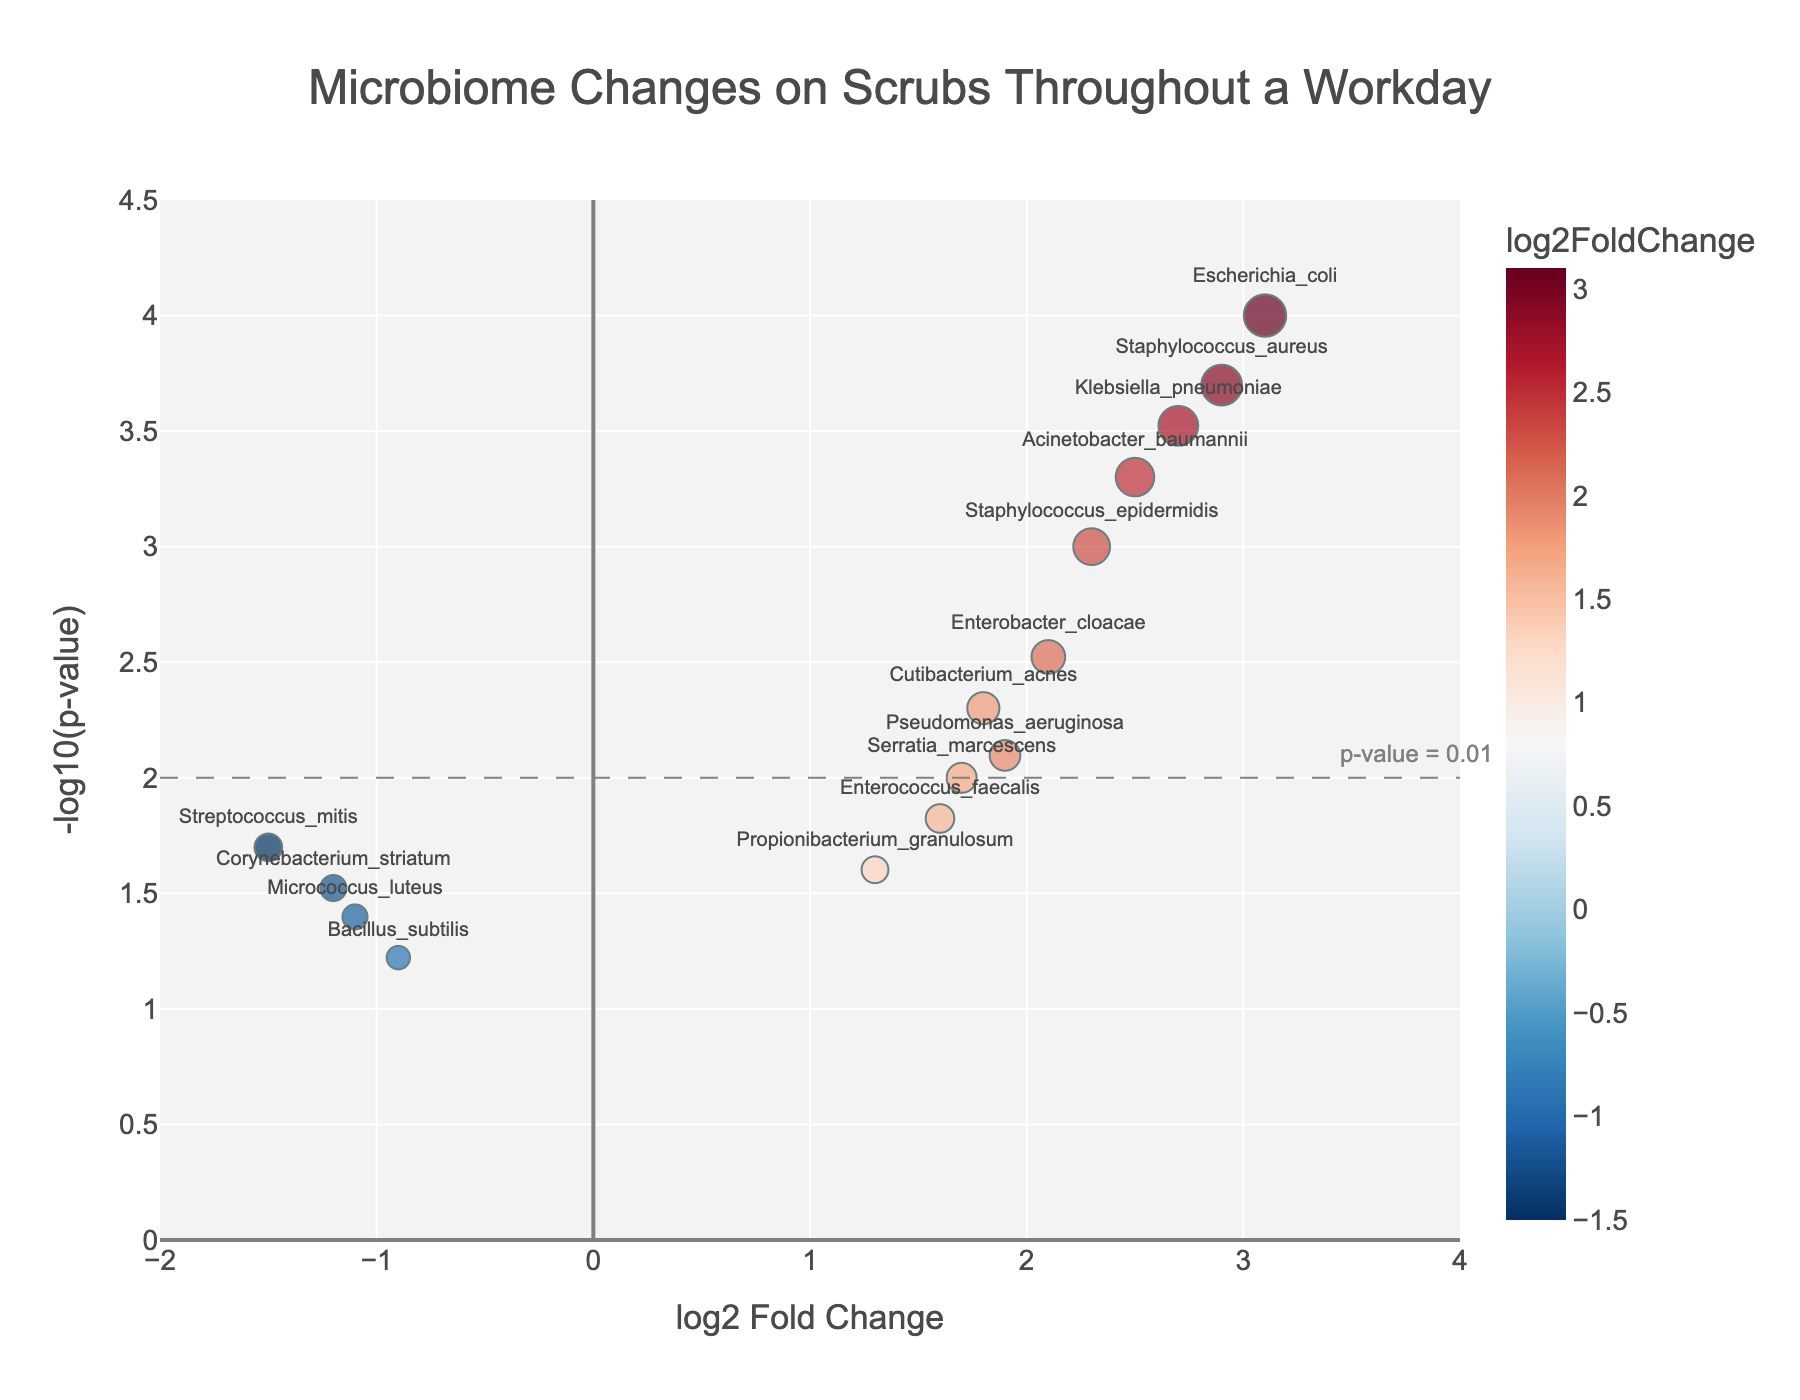What's the title of the plot? The title of the plot is located at the top center of the figure. It is usually in large, bold text.
Answer: Microbiome Changes on Scrubs Throughout a Workday What are the labels for the x-axis and y-axis? Axis labels are placed near their respective axes. The x-axis label is at the bottom of the plot and the y-axis label is to the left of the plot.
Answer: log2 Fold Change and -log10(p-value) How many data points show a significant increase in microbiome presence (p-value < 0.01)? You can count the number of data points that fall above the dashed horizontal line at y = 2, which represents -log10(0.01).
Answer: 8 Which species has the highest log2 Fold Change and what is its value? Look for the data point farthest to the right on the x-axis. The label next to it will indicate the species, and its position on the x-axis shows its log2 Fold Change value.
Answer: Escherichia coli, 3.1 What is the range of the x-axis in the plot? The range of the x-axis is indicated by the values at both ends of the axis.
Answer: -2 to 4 Which species has the lowest p-value and what is its log2 Fold Change? The species with the lowest p-value will be the highest point on the y-axis. The label next to this point shows the species name, and its position on the x-axis indicates its log2 Fold Change.
Answer: Escherichia coli, 3.1 How many species have a log2 Fold Change greater than 1.5? Count the data points that are to the right of x = 1.5.
Answer: 10 For species with log2 Fold Change less than zero, which one has the lowest p-value? Look at the data points left of the y-axis (log2 Fold Change < 0) and identify the one highest on the y-axis. The label next to this point indicates the species.
Answer: Streptococcus mitis What is the log2 Fold Change of Staphylococcus aureus and its significance level in terms of p-value? Locate the data point labeled Staphylococcus aureus. Read its x-axis (log2 Fold Change) and y-axis (-log10(p-value)) values. Convert y-axis value to p-value as p = 10^-y.
Answer: 2.9, 0.0002 